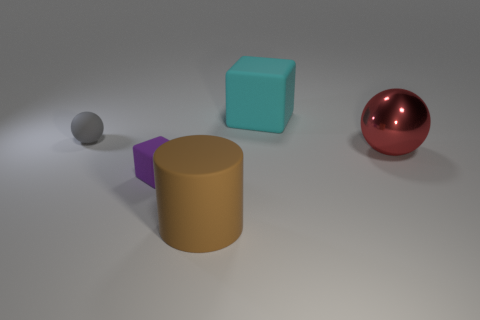Subtract all red spheres. How many spheres are left? 1 Add 1 tiny gray matte spheres. How many objects exist? 6 Subtract all cubes. How many objects are left? 3 Add 3 matte blocks. How many matte blocks are left? 5 Add 1 small purple things. How many small purple things exist? 2 Subtract 0 yellow cubes. How many objects are left? 5 Subtract 2 balls. How many balls are left? 0 Subtract all blue balls. Subtract all green cylinders. How many balls are left? 2 Subtract all red cylinders. How many yellow cubes are left? 0 Subtract all big matte blocks. Subtract all purple matte cylinders. How many objects are left? 4 